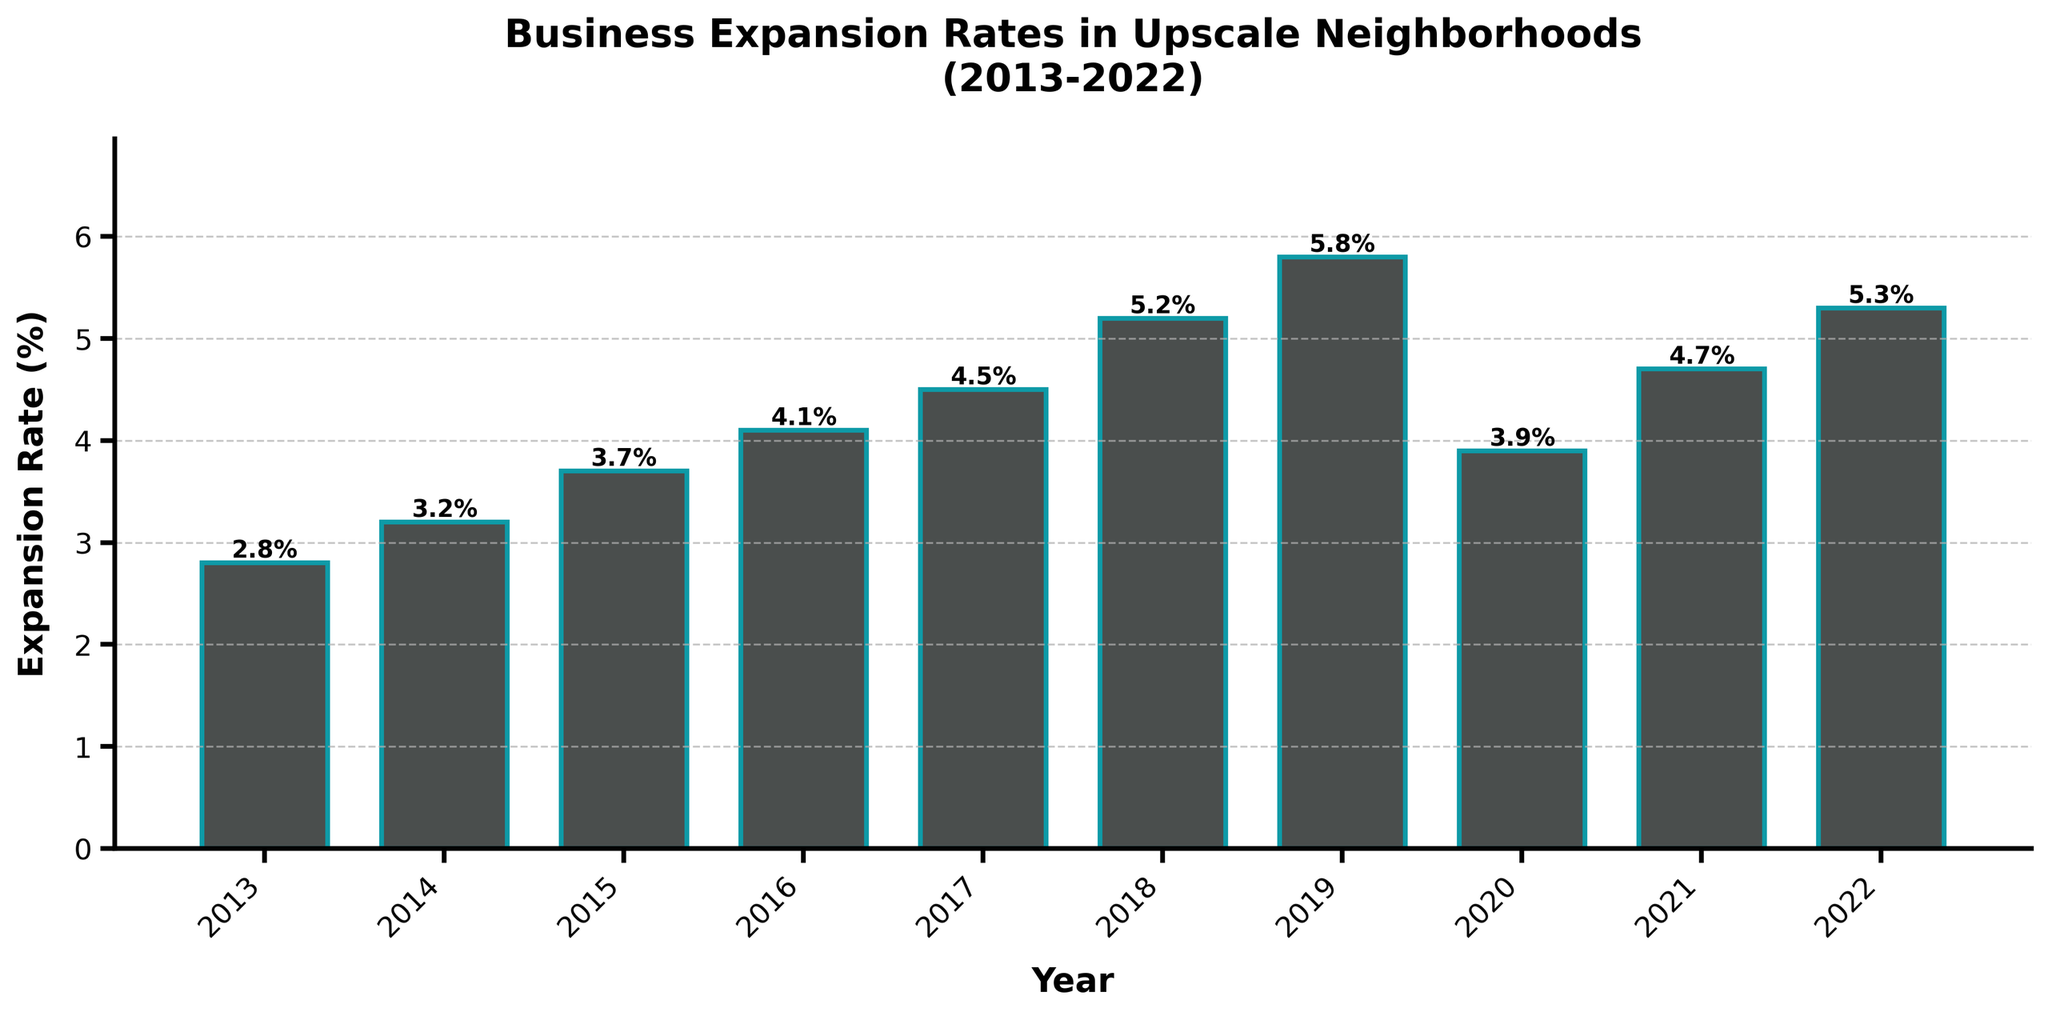What was the highest business expansion rate during the years shown? The highest expansion rate can be identified by looking for the tallest bar in the chart. The highest bar corresponds to the year 2019 with an expansion rate of 5.8%.
Answer: 5.8% Which year had the lowest business expansion rate? The lowest expansion rate can be found by identifying the shortest bar in the chart. The shortest bar corresponds to the year 2013 with an expansion rate of 2.8%.
Answer: 2013 How does the expansion rate in 2022 compare to that in 2020? To compare, we need to look at the bars for the years 2022 and 2020. The bar for 2022 is taller than the bar for 2020, indicating that the expansion rate in 2022 (5.3%) is higher than in 2020 (3.9%).
Answer: Higher By how much did the expansion rate change from 2018 to 2019? To find the change in expansion rates, subtract the expansion rate in 2018 from that in 2019. The expansion rate in 2019 was 5.8%, and in 2018 it was 5.2%, so the change is 5.8% - 5.2% = 0.6%.
Answer: 0.6% What is the average expansion rate from 2013 to 2022? Sum the expansion rates for all the years (2.8 + 3.2 + 3.7 + 4.1 + 4.5 + 5.2 + 5.8 + 3.9 + 4.7 + 5.3), which equals 43.2. Divide by the number of years (10): 43.2 / 10 = 4.32%.
Answer: 4.32% What can be inferred about the trend in business expansion rates from 2013 to 2022? The overall trend can be analyzed by observing the general direction of the bars across the years. The bars generally increase in height from 2013 to 2019, dip in 2020, and then rise again in 2021 and 2022, indicating an overall upward trend with a slight dip in 2020.
Answer: Upward trend By what percentage did the expansion rate increase from 2013 to 2019? Calculate the percentage increase from 2013 to 2019 by subtracting the 2013 rate from the 2019 rate and dividing by the 2013 rate. (5.8% - 2.8%) / 2.8% * 100 = 107.14%
Answer: 107.14% In which years did the expansion rate increase every consecutive year? Identify the years where each year's expansion rate is higher than the previous year's. The rates increase consecutively from 2013 to 2019.
Answer: 2013 to 2019 Which year had an expansion rate closest to the average rate of the decade (2013-2022)? Compute the average rate for the decade (4.32%) and find the year with an expansion rate nearest to this average. The closest is the year 2021 with an expansion rate of 4.7%.
Answer: 2021 What is the difference between the highest and lowest expansion rates in the past decade? Subtract the lowest expansion rate from the highest expansion rate: 5.8% (2019) - 2.8% (2013) = 3.0%.
Answer: 3.0% 